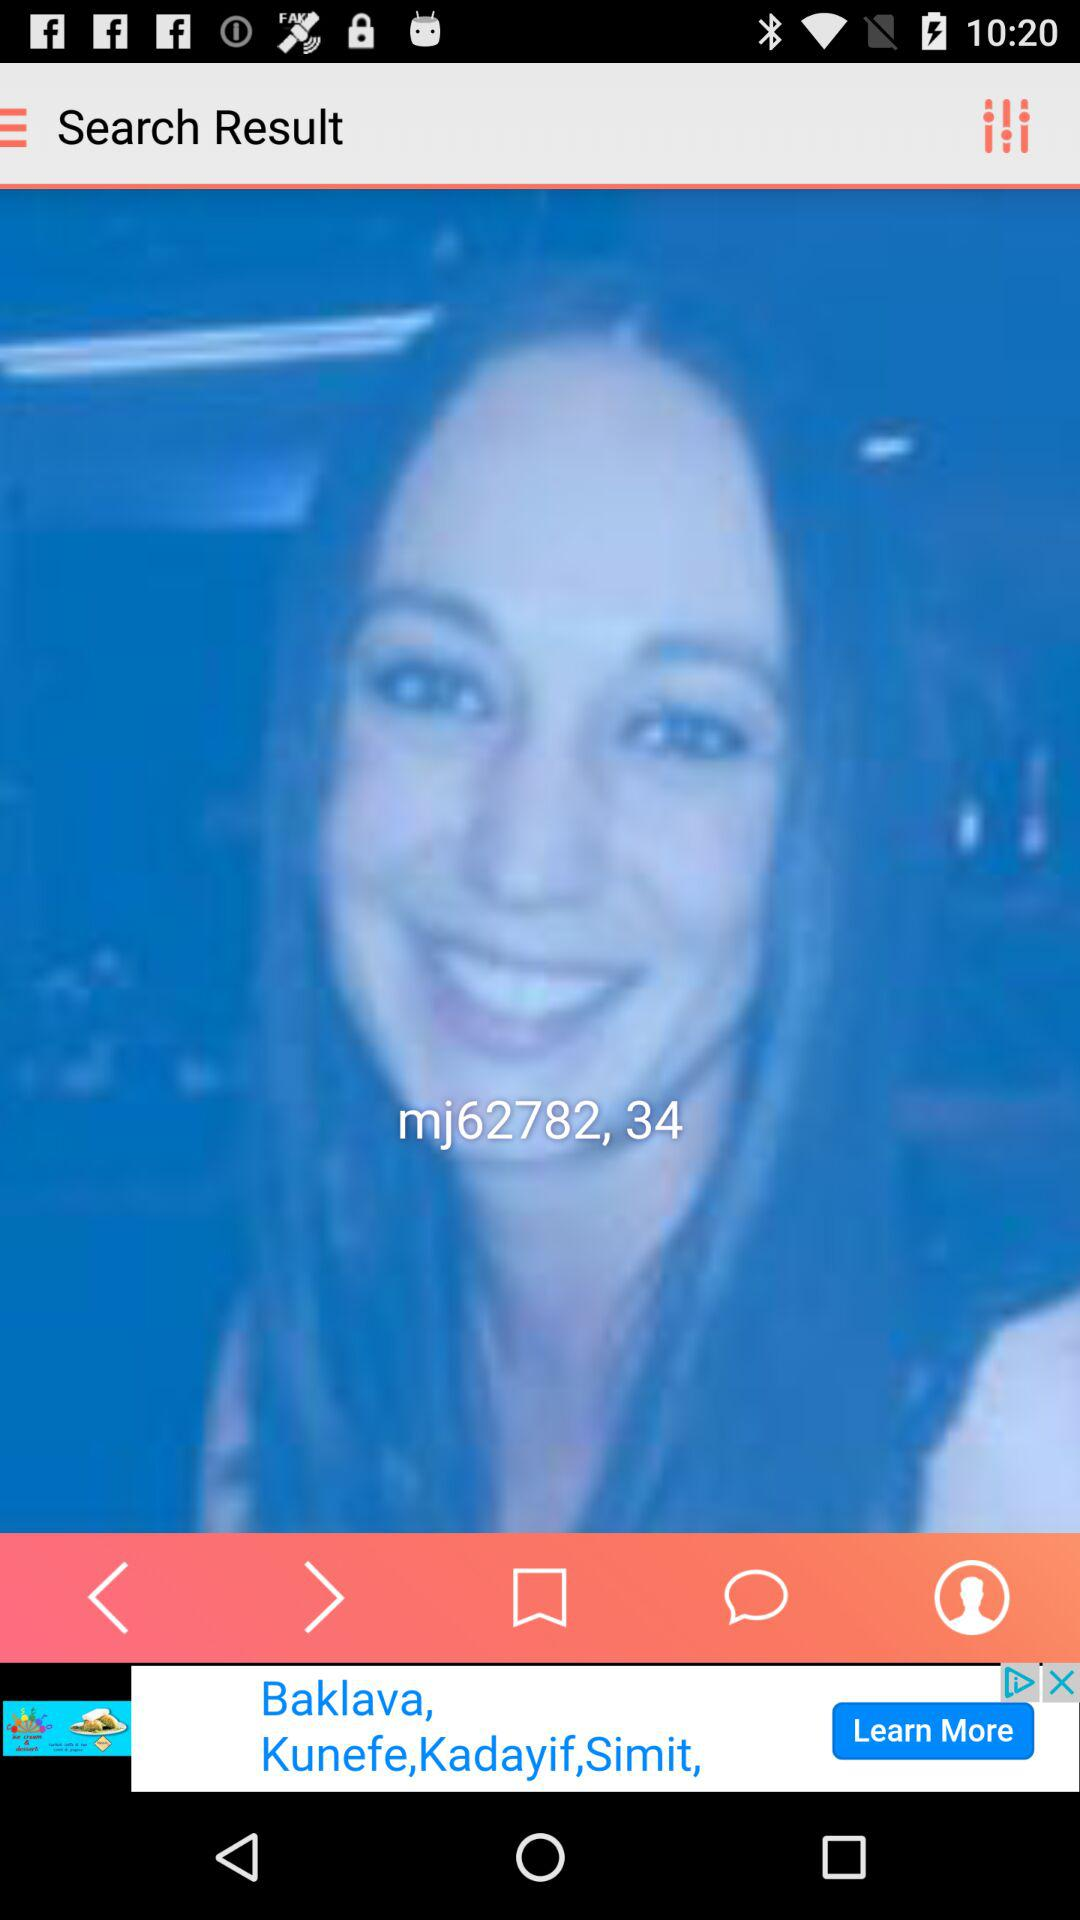What's the profile name? The profile name is "mj62782". 